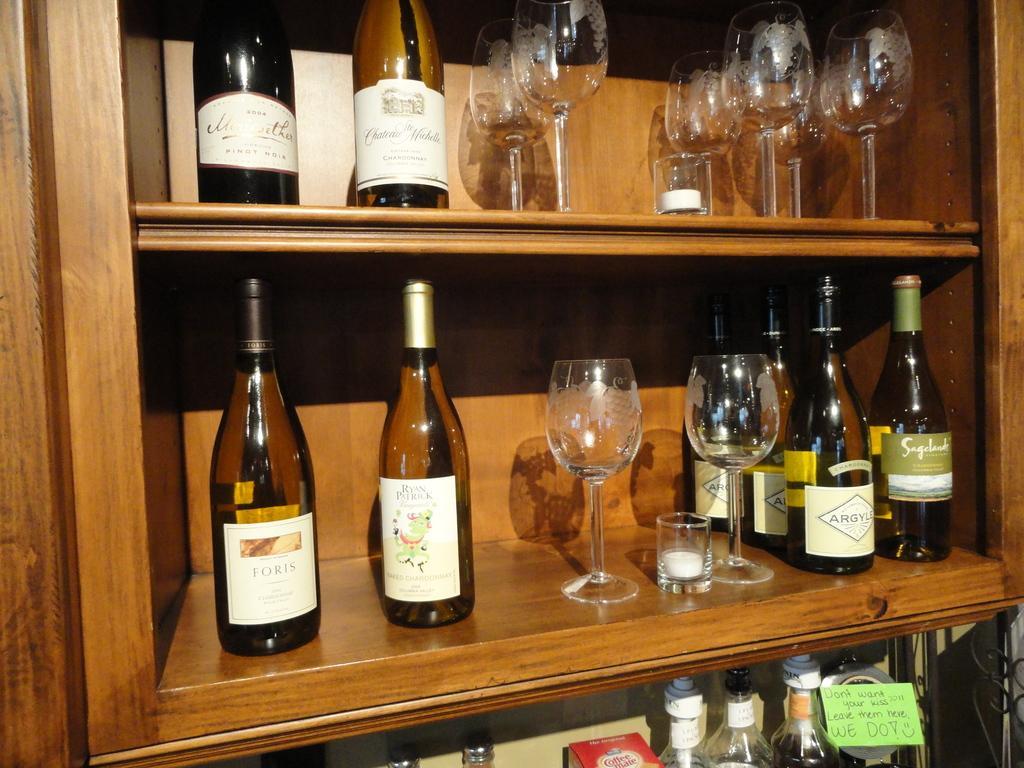Please provide a concise description of this image. In this image I can see few bottles and few glasses. 